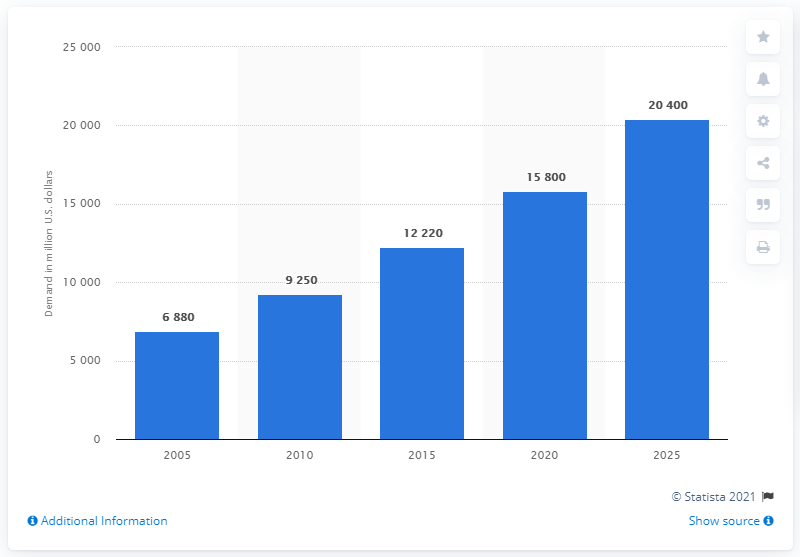Specify some key components in this picture. In 2005, the demand for raw materials for medical disposables was 6,880 units. In 2015, the demand for raw materials for medical disposables was valued at approximately 12,220... According to a forecast, the market value for raw materials used in the production of medical disposables is expected to reach 20,400 by 2025. 